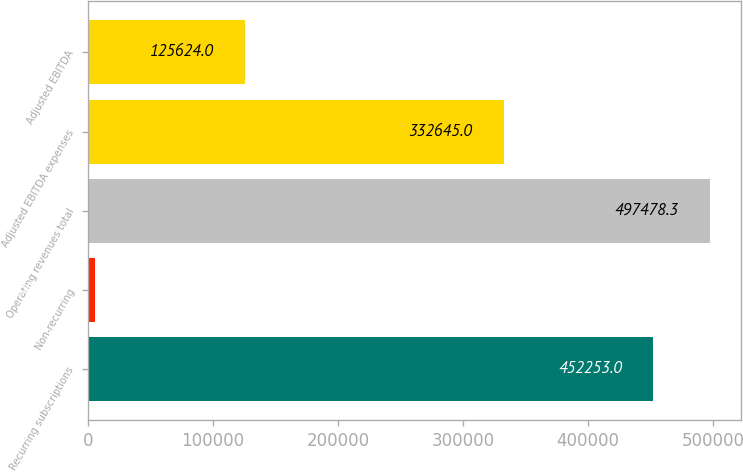<chart> <loc_0><loc_0><loc_500><loc_500><bar_chart><fcel>Recurring subscriptions<fcel>Non-recurring<fcel>Operating revenues total<fcel>Adjusted EBITDA expenses<fcel>Adjusted EBITDA<nl><fcel>452253<fcel>6016<fcel>497478<fcel>332645<fcel>125624<nl></chart> 